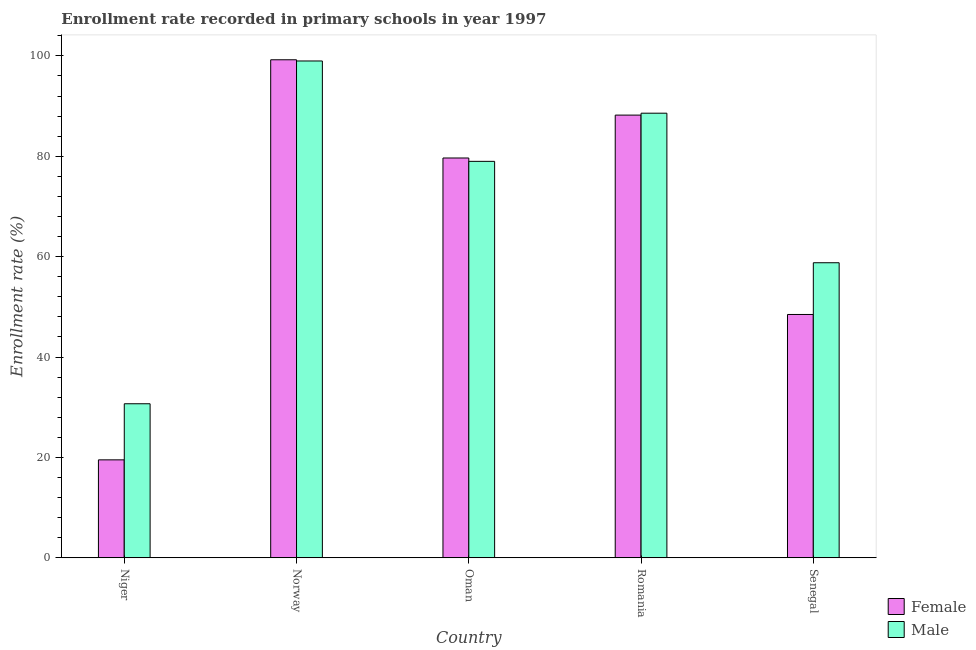How many different coloured bars are there?
Make the answer very short. 2. Are the number of bars per tick equal to the number of legend labels?
Your response must be concise. Yes. Are the number of bars on each tick of the X-axis equal?
Your response must be concise. Yes. What is the label of the 3rd group of bars from the left?
Keep it short and to the point. Oman. In how many cases, is the number of bars for a given country not equal to the number of legend labels?
Make the answer very short. 0. What is the enrollment rate of female students in Romania?
Keep it short and to the point. 88.2. Across all countries, what is the maximum enrollment rate of male students?
Ensure brevity in your answer.  98.99. Across all countries, what is the minimum enrollment rate of male students?
Give a very brief answer. 30.68. In which country was the enrollment rate of male students minimum?
Offer a very short reply. Niger. What is the total enrollment rate of male students in the graph?
Ensure brevity in your answer.  356.02. What is the difference between the enrollment rate of female students in Norway and that in Senegal?
Offer a terse response. 50.75. What is the difference between the enrollment rate of female students in Oman and the enrollment rate of male students in Romania?
Ensure brevity in your answer.  -8.93. What is the average enrollment rate of female students per country?
Your response must be concise. 67.01. What is the difference between the enrollment rate of male students and enrollment rate of female students in Senegal?
Offer a terse response. 10.31. In how many countries, is the enrollment rate of female students greater than 60 %?
Keep it short and to the point. 3. What is the ratio of the enrollment rate of female students in Norway to that in Oman?
Give a very brief answer. 1.25. Is the enrollment rate of male students in Niger less than that in Senegal?
Offer a terse response. Yes. What is the difference between the highest and the second highest enrollment rate of male students?
Provide a succinct answer. 10.41. What is the difference between the highest and the lowest enrollment rate of male students?
Make the answer very short. 68.3. What does the 1st bar from the left in Romania represents?
Make the answer very short. Female. What does the 1st bar from the right in Oman represents?
Offer a terse response. Male. How many bars are there?
Provide a short and direct response. 10. Does the graph contain any zero values?
Offer a very short reply. No. Does the graph contain grids?
Provide a succinct answer. No. Where does the legend appear in the graph?
Ensure brevity in your answer.  Bottom right. How are the legend labels stacked?
Provide a succinct answer. Vertical. What is the title of the graph?
Your answer should be compact. Enrollment rate recorded in primary schools in year 1997. What is the label or title of the X-axis?
Provide a short and direct response. Country. What is the label or title of the Y-axis?
Provide a short and direct response. Enrollment rate (%). What is the Enrollment rate (%) of Female in Niger?
Your response must be concise. 19.51. What is the Enrollment rate (%) of Male in Niger?
Offer a terse response. 30.68. What is the Enrollment rate (%) of Female in Norway?
Provide a short and direct response. 99.23. What is the Enrollment rate (%) in Male in Norway?
Offer a very short reply. 98.99. What is the Enrollment rate (%) in Female in Oman?
Your answer should be compact. 79.66. What is the Enrollment rate (%) in Male in Oman?
Give a very brief answer. 78.99. What is the Enrollment rate (%) of Female in Romania?
Offer a very short reply. 88.2. What is the Enrollment rate (%) of Male in Romania?
Your response must be concise. 88.58. What is the Enrollment rate (%) in Female in Senegal?
Make the answer very short. 48.47. What is the Enrollment rate (%) of Male in Senegal?
Your answer should be compact. 58.78. Across all countries, what is the maximum Enrollment rate (%) in Female?
Your answer should be compact. 99.23. Across all countries, what is the maximum Enrollment rate (%) in Male?
Give a very brief answer. 98.99. Across all countries, what is the minimum Enrollment rate (%) in Female?
Make the answer very short. 19.51. Across all countries, what is the minimum Enrollment rate (%) of Male?
Make the answer very short. 30.68. What is the total Enrollment rate (%) of Female in the graph?
Your response must be concise. 335.06. What is the total Enrollment rate (%) in Male in the graph?
Make the answer very short. 356.02. What is the difference between the Enrollment rate (%) of Female in Niger and that in Norway?
Your answer should be very brief. -79.72. What is the difference between the Enrollment rate (%) of Male in Niger and that in Norway?
Make the answer very short. -68.3. What is the difference between the Enrollment rate (%) in Female in Niger and that in Oman?
Give a very brief answer. -60.15. What is the difference between the Enrollment rate (%) of Male in Niger and that in Oman?
Keep it short and to the point. -48.3. What is the difference between the Enrollment rate (%) of Female in Niger and that in Romania?
Keep it short and to the point. -68.69. What is the difference between the Enrollment rate (%) of Male in Niger and that in Romania?
Provide a succinct answer. -57.9. What is the difference between the Enrollment rate (%) in Female in Niger and that in Senegal?
Your answer should be compact. -28.96. What is the difference between the Enrollment rate (%) in Male in Niger and that in Senegal?
Provide a succinct answer. -28.1. What is the difference between the Enrollment rate (%) of Female in Norway and that in Oman?
Provide a short and direct response. 19.57. What is the difference between the Enrollment rate (%) of Male in Norway and that in Oman?
Offer a very short reply. 20. What is the difference between the Enrollment rate (%) of Female in Norway and that in Romania?
Your answer should be compact. 11.03. What is the difference between the Enrollment rate (%) in Male in Norway and that in Romania?
Your answer should be very brief. 10.41. What is the difference between the Enrollment rate (%) of Female in Norway and that in Senegal?
Ensure brevity in your answer.  50.75. What is the difference between the Enrollment rate (%) in Male in Norway and that in Senegal?
Make the answer very short. 40.2. What is the difference between the Enrollment rate (%) of Female in Oman and that in Romania?
Provide a succinct answer. -8.54. What is the difference between the Enrollment rate (%) in Male in Oman and that in Romania?
Keep it short and to the point. -9.6. What is the difference between the Enrollment rate (%) of Female in Oman and that in Senegal?
Your answer should be compact. 31.18. What is the difference between the Enrollment rate (%) of Male in Oman and that in Senegal?
Provide a short and direct response. 20.2. What is the difference between the Enrollment rate (%) of Female in Romania and that in Senegal?
Your answer should be compact. 39.73. What is the difference between the Enrollment rate (%) in Male in Romania and that in Senegal?
Your answer should be compact. 29.8. What is the difference between the Enrollment rate (%) of Female in Niger and the Enrollment rate (%) of Male in Norway?
Offer a very short reply. -79.48. What is the difference between the Enrollment rate (%) in Female in Niger and the Enrollment rate (%) in Male in Oman?
Your answer should be very brief. -59.48. What is the difference between the Enrollment rate (%) of Female in Niger and the Enrollment rate (%) of Male in Romania?
Provide a short and direct response. -69.07. What is the difference between the Enrollment rate (%) of Female in Niger and the Enrollment rate (%) of Male in Senegal?
Offer a very short reply. -39.28. What is the difference between the Enrollment rate (%) of Female in Norway and the Enrollment rate (%) of Male in Oman?
Make the answer very short. 20.24. What is the difference between the Enrollment rate (%) of Female in Norway and the Enrollment rate (%) of Male in Romania?
Ensure brevity in your answer.  10.64. What is the difference between the Enrollment rate (%) of Female in Norway and the Enrollment rate (%) of Male in Senegal?
Your response must be concise. 40.44. What is the difference between the Enrollment rate (%) of Female in Oman and the Enrollment rate (%) of Male in Romania?
Your answer should be very brief. -8.93. What is the difference between the Enrollment rate (%) in Female in Oman and the Enrollment rate (%) in Male in Senegal?
Provide a succinct answer. 20.87. What is the difference between the Enrollment rate (%) in Female in Romania and the Enrollment rate (%) in Male in Senegal?
Give a very brief answer. 29.42. What is the average Enrollment rate (%) of Female per country?
Your answer should be very brief. 67.01. What is the average Enrollment rate (%) of Male per country?
Provide a succinct answer. 71.2. What is the difference between the Enrollment rate (%) of Female and Enrollment rate (%) of Male in Niger?
Make the answer very short. -11.17. What is the difference between the Enrollment rate (%) of Female and Enrollment rate (%) of Male in Norway?
Provide a short and direct response. 0.24. What is the difference between the Enrollment rate (%) of Female and Enrollment rate (%) of Male in Oman?
Offer a terse response. 0.67. What is the difference between the Enrollment rate (%) of Female and Enrollment rate (%) of Male in Romania?
Make the answer very short. -0.38. What is the difference between the Enrollment rate (%) of Female and Enrollment rate (%) of Male in Senegal?
Keep it short and to the point. -10.31. What is the ratio of the Enrollment rate (%) in Female in Niger to that in Norway?
Offer a very short reply. 0.2. What is the ratio of the Enrollment rate (%) in Male in Niger to that in Norway?
Your answer should be very brief. 0.31. What is the ratio of the Enrollment rate (%) in Female in Niger to that in Oman?
Make the answer very short. 0.24. What is the ratio of the Enrollment rate (%) in Male in Niger to that in Oman?
Your response must be concise. 0.39. What is the ratio of the Enrollment rate (%) in Female in Niger to that in Romania?
Ensure brevity in your answer.  0.22. What is the ratio of the Enrollment rate (%) in Male in Niger to that in Romania?
Make the answer very short. 0.35. What is the ratio of the Enrollment rate (%) of Female in Niger to that in Senegal?
Your answer should be very brief. 0.4. What is the ratio of the Enrollment rate (%) of Male in Niger to that in Senegal?
Provide a short and direct response. 0.52. What is the ratio of the Enrollment rate (%) in Female in Norway to that in Oman?
Ensure brevity in your answer.  1.25. What is the ratio of the Enrollment rate (%) in Male in Norway to that in Oman?
Make the answer very short. 1.25. What is the ratio of the Enrollment rate (%) in Male in Norway to that in Romania?
Ensure brevity in your answer.  1.12. What is the ratio of the Enrollment rate (%) of Female in Norway to that in Senegal?
Provide a succinct answer. 2.05. What is the ratio of the Enrollment rate (%) in Male in Norway to that in Senegal?
Provide a short and direct response. 1.68. What is the ratio of the Enrollment rate (%) in Female in Oman to that in Romania?
Your response must be concise. 0.9. What is the ratio of the Enrollment rate (%) in Male in Oman to that in Romania?
Provide a short and direct response. 0.89. What is the ratio of the Enrollment rate (%) in Female in Oman to that in Senegal?
Your answer should be compact. 1.64. What is the ratio of the Enrollment rate (%) of Male in Oman to that in Senegal?
Your answer should be compact. 1.34. What is the ratio of the Enrollment rate (%) in Female in Romania to that in Senegal?
Your answer should be very brief. 1.82. What is the ratio of the Enrollment rate (%) in Male in Romania to that in Senegal?
Ensure brevity in your answer.  1.51. What is the difference between the highest and the second highest Enrollment rate (%) in Female?
Make the answer very short. 11.03. What is the difference between the highest and the second highest Enrollment rate (%) of Male?
Make the answer very short. 10.41. What is the difference between the highest and the lowest Enrollment rate (%) of Female?
Your answer should be very brief. 79.72. What is the difference between the highest and the lowest Enrollment rate (%) of Male?
Make the answer very short. 68.3. 